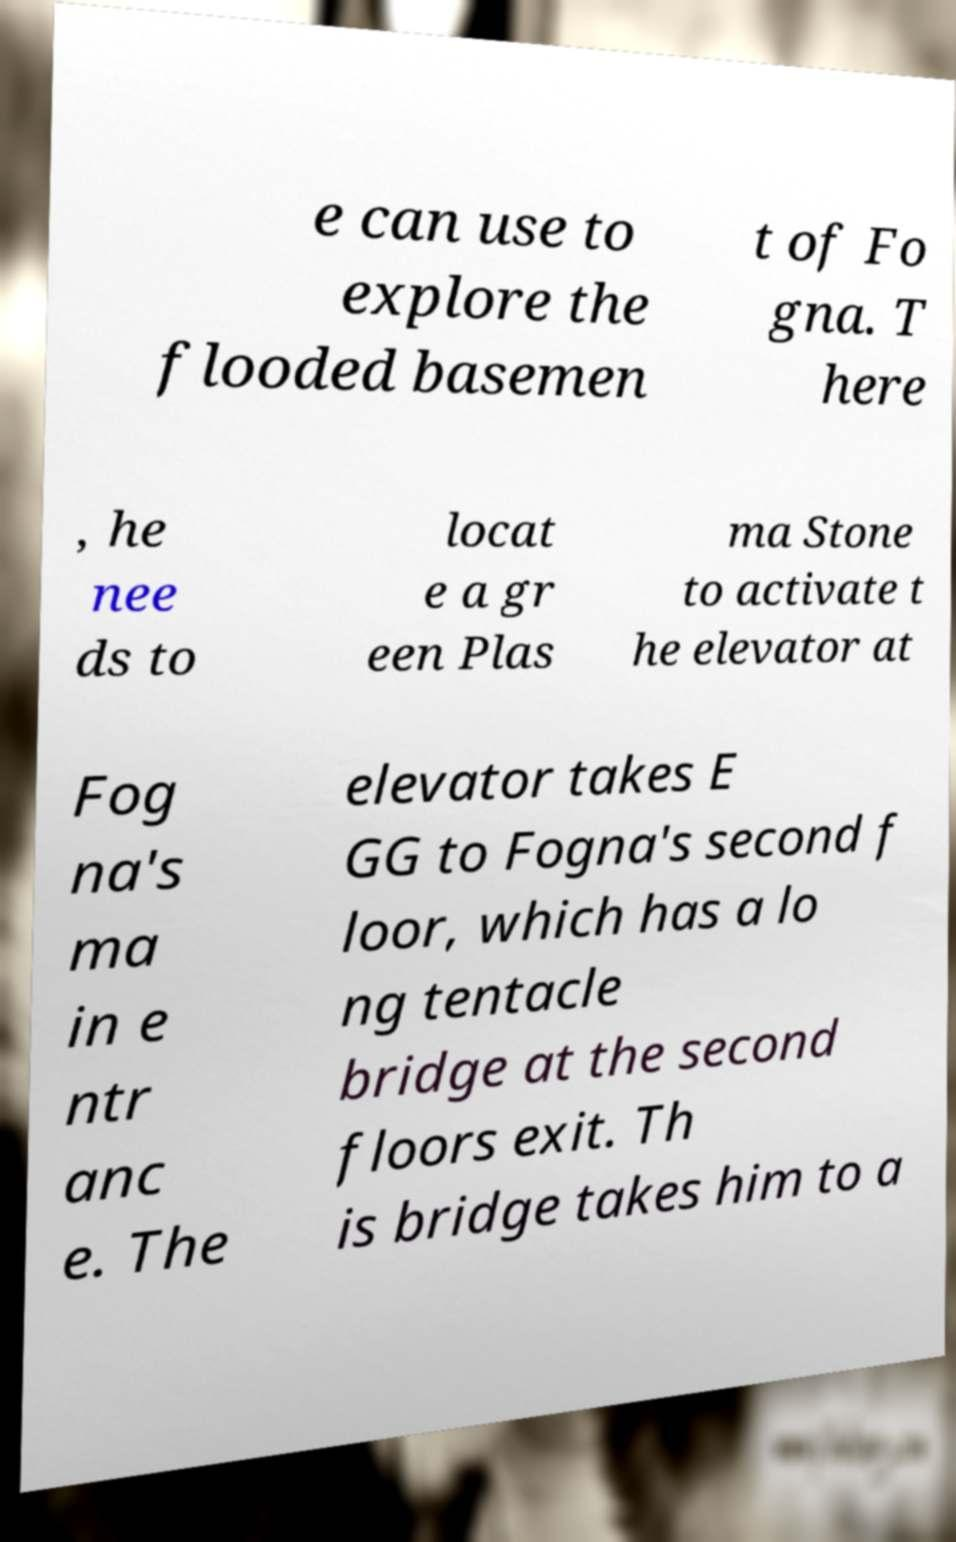Can you read and provide the text displayed in the image?This photo seems to have some interesting text. Can you extract and type it out for me? e can use to explore the flooded basemen t of Fo gna. T here , he nee ds to locat e a gr een Plas ma Stone to activate t he elevator at Fog na's ma in e ntr anc e. The elevator takes E GG to Fogna's second f loor, which has a lo ng tentacle bridge at the second floors exit. Th is bridge takes him to a 